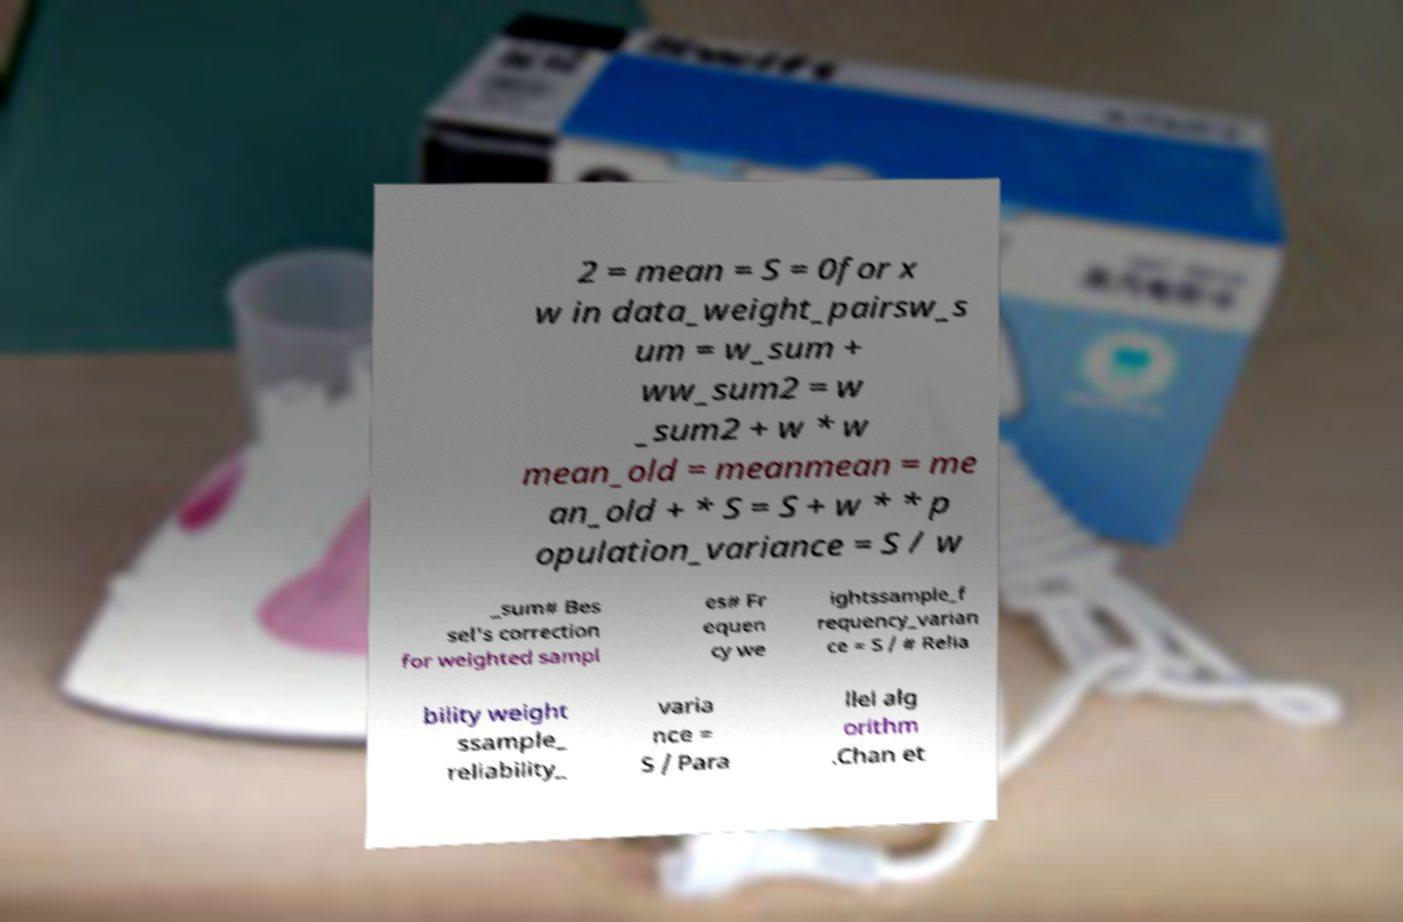Could you assist in decoding the text presented in this image and type it out clearly? 2 = mean = S = 0for x w in data_weight_pairsw_s um = w_sum + ww_sum2 = w _sum2 + w * w mean_old = meanmean = me an_old + * S = S + w * * p opulation_variance = S / w _sum# Bes sel's correction for weighted sampl es# Fr equen cy we ightssample_f requency_varian ce = S / # Relia bility weight ssample_ reliability_ varia nce = S / Para llel alg orithm .Chan et 